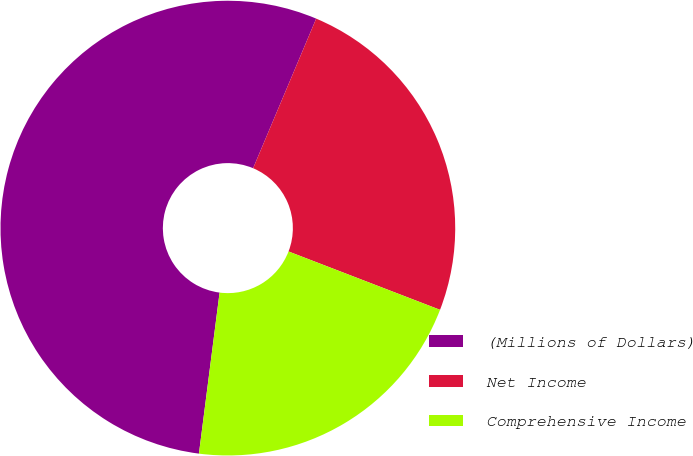<chart> <loc_0><loc_0><loc_500><loc_500><pie_chart><fcel>(Millions of Dollars)<fcel>Net Income<fcel>Comprehensive Income<nl><fcel>54.32%<fcel>24.5%<fcel>21.18%<nl></chart> 